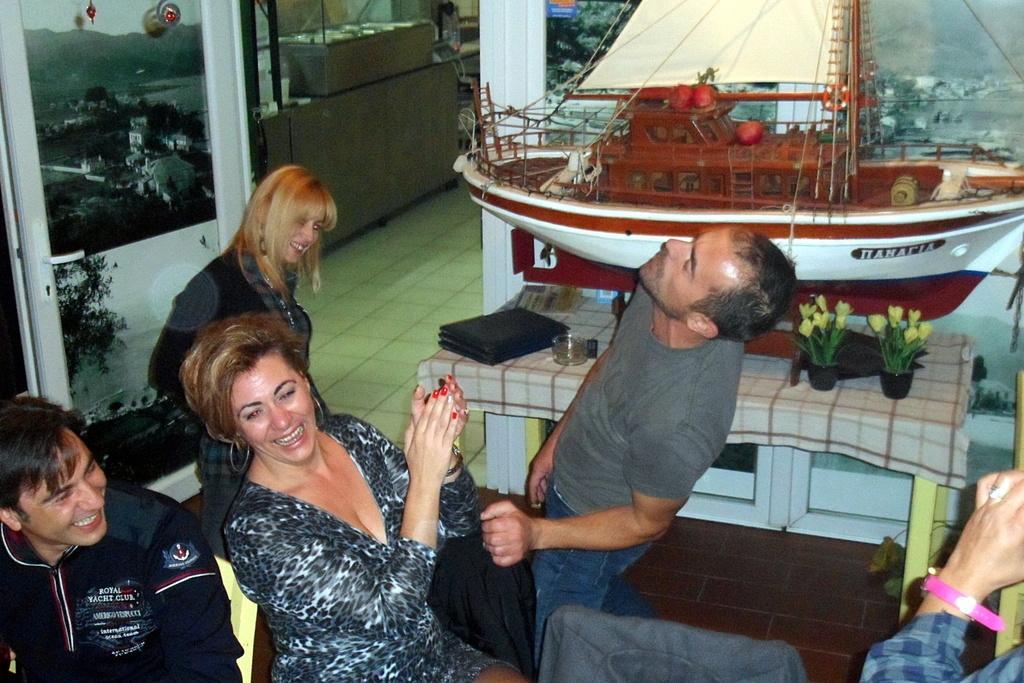Could you give a brief overview of what you see in this image? There are people in the foreground area of the image, there are plant pots, a model of a ship, other objects, door, it seems like mountains and the sky in the background. 